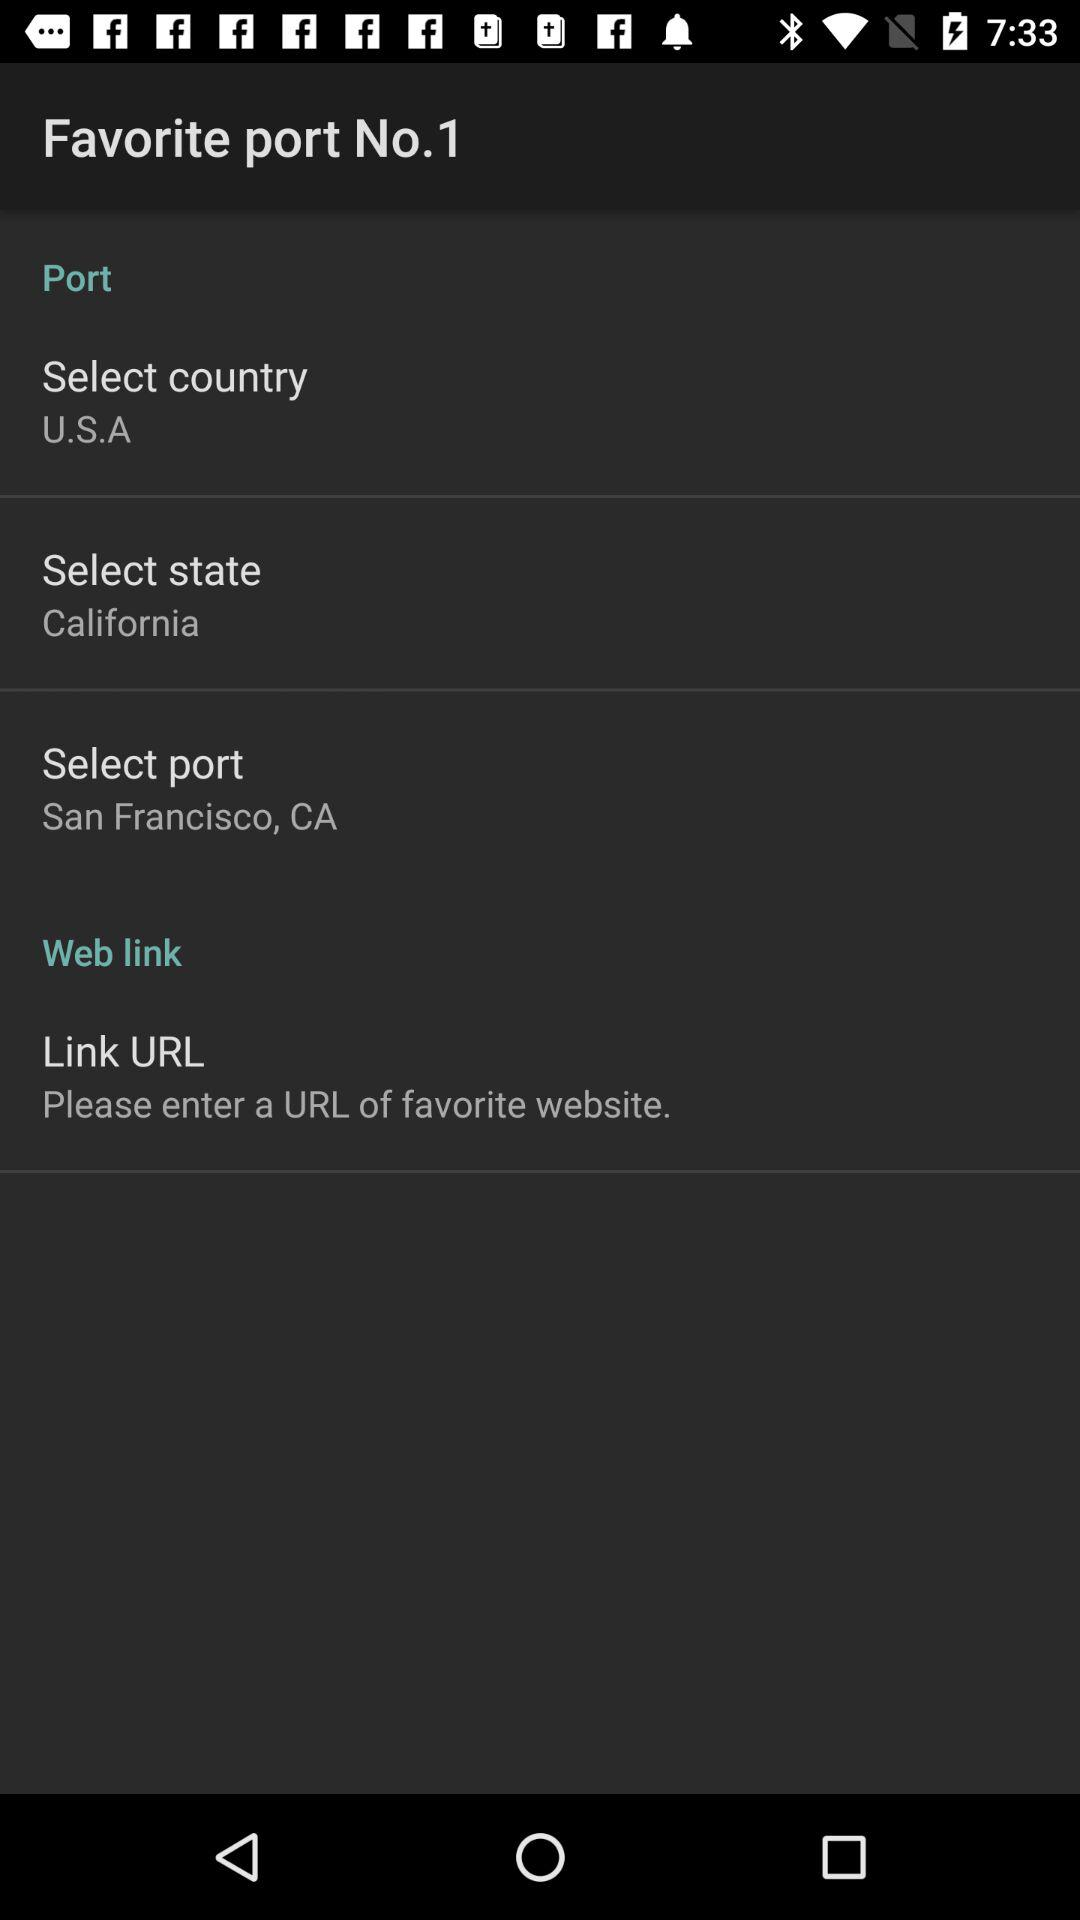What is the selected country? The selected country is U.S.A. 